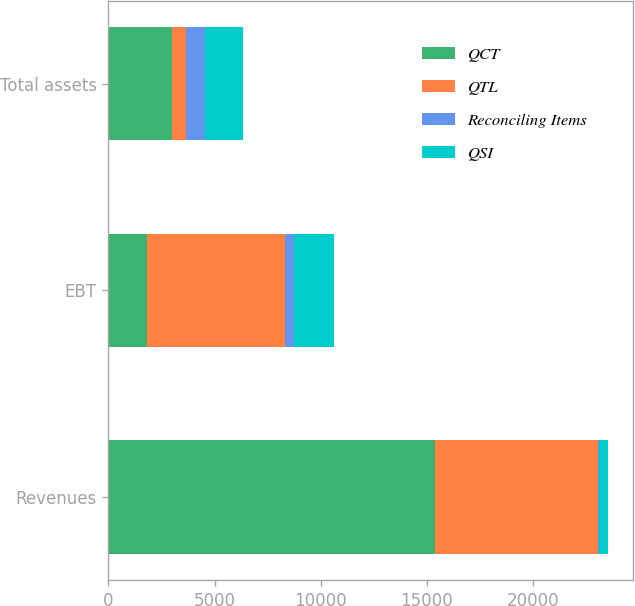Convert chart. <chart><loc_0><loc_0><loc_500><loc_500><stacked_bar_chart><ecel><fcel>Revenues<fcel>EBT<fcel>Total assets<nl><fcel>QCT<fcel>15409<fcel>1812<fcel>2995<nl><fcel>QTL<fcel>7664<fcel>6528<fcel>644<nl><fcel>Reconciling Items<fcel>47<fcel>386<fcel>910<nl><fcel>QSI<fcel>434<fcel>1893<fcel>1812<nl></chart> 